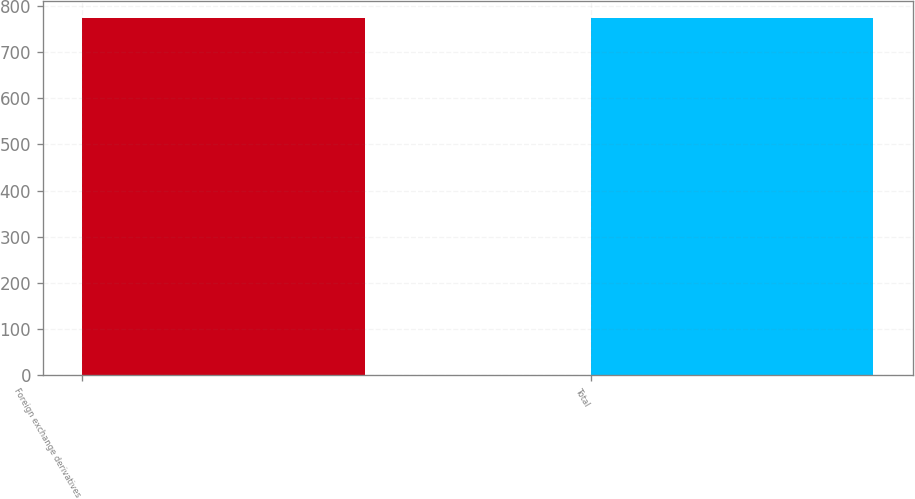Convert chart to OTSL. <chart><loc_0><loc_0><loc_500><loc_500><bar_chart><fcel>Foreign exchange derivatives<fcel>Total<nl><fcel>773<fcel>773.1<nl></chart> 